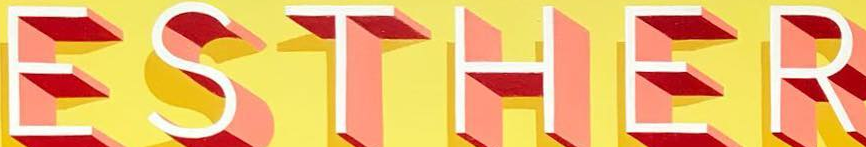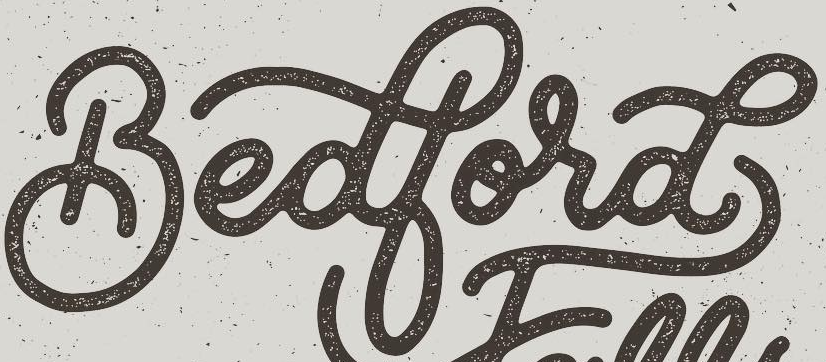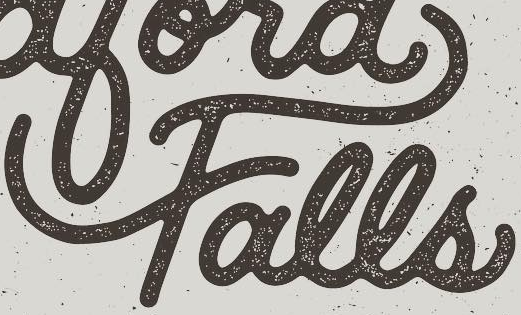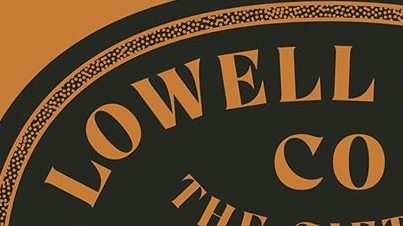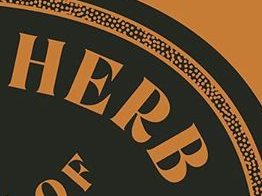What words are shown in these images in order, separated by a semicolon? ESTHER; Bedbord; Falls; LOWELL; HERB 